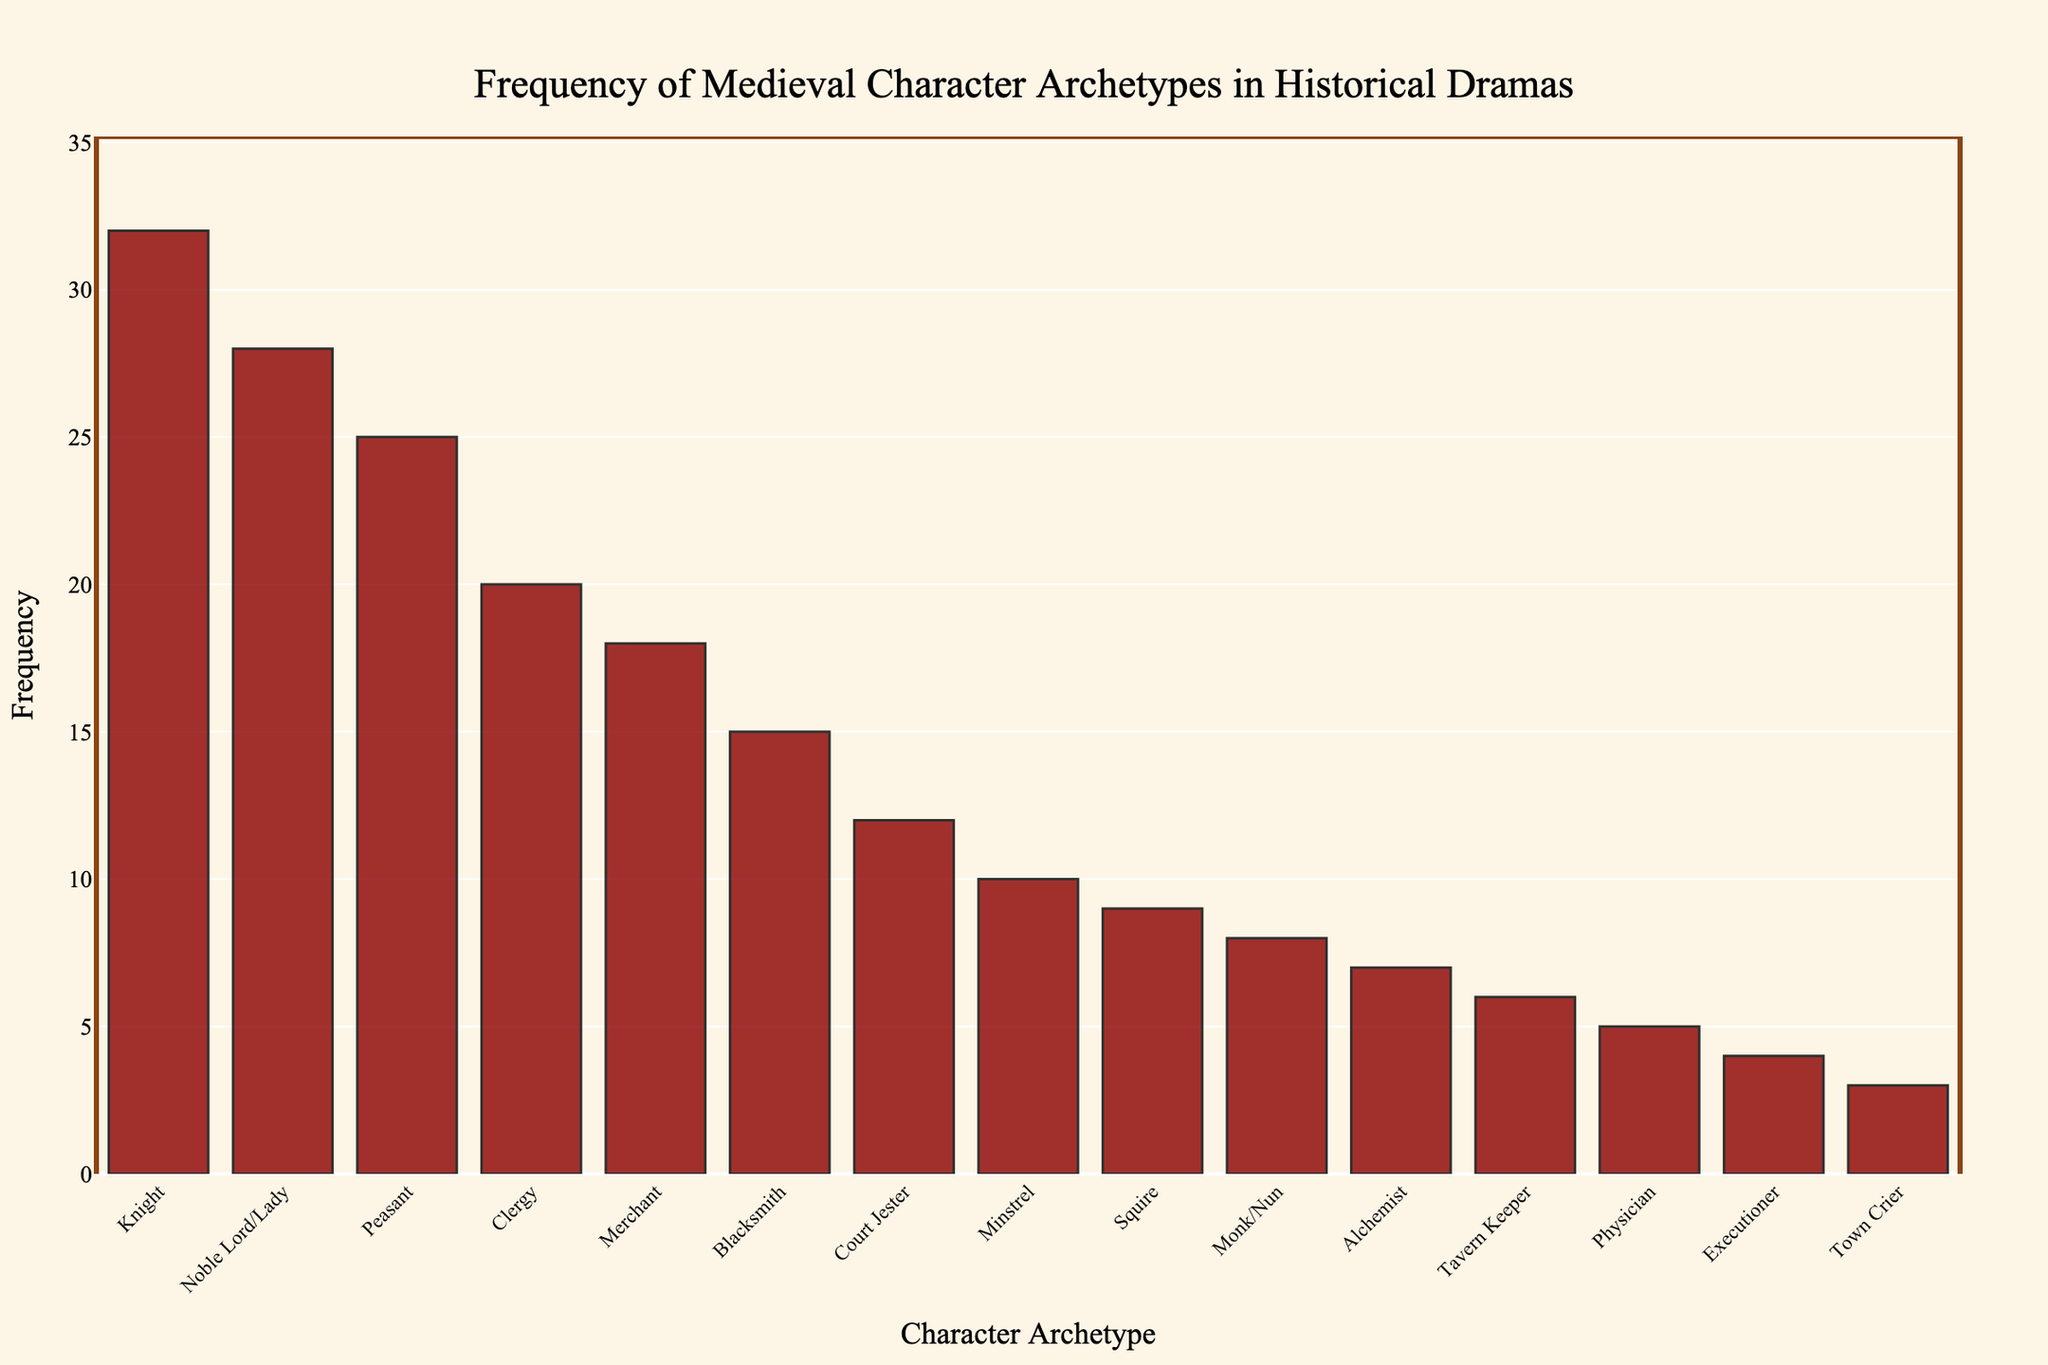Which character archetype appears most frequently in historical dramas? The tallest bar represents the frequency of the most common archetype in the chart. The knight has the highest bar.
Answer: Knight Which character archetype appears least frequently in historical dramas? The smallest bar represents the frequency of the least common archetype. The Town Crier has the shortest bar.
Answer: Town Crier What is the combined frequency of the Knight and the Noble Lord/Lady archetypes? Add the frequencies of the Knight and the Noble Lord/Lady archetypes. Knight: 32, Noble Lord/Lady: 28. Combined frequency = 32 + 28.
Answer: 60 How does the frequency of the Peasant archetype compare to that of the Merchant? Compare the heights of the bars representing the Peasant and the Merchant. Peasant (25) is higher than Merchant (18), so the Peasant archetype is more frequent.
Answer: Peasant is more frequent What is the difference in frequency between the Blacksmith and the Executioner archetypes? Subtract the frequency of the Executioner (4) from the frequency of the Blacksmith (15). Difference = 15 - 4.
Answer: 11 Which archetype is more frequent: Minstrel or Monk/Nun? Compare the heights of the bars representing Minstrel (10) and Monk/Nun (8). The Minstrel's bar is higher.
Answer: Minstrel What is the average frequency of the top three most frequent archetypes? Find the frequencies of the top three archetypes and then calculate the average. Top three: Knight (32), Noble Lord/Lady (28), Peasant (25). Average = (32 + 28 + 25) / 3.
Answer: 28.33 How many archetypes have a frequency greater than 20? Count the number of bars that have a height greater than 20. The archetypes with frequencies > 20 are Knight, Noble Lord/Lady, and Peasant.
Answer: 3 What is the total frequency of all the archetypes portrayed in historical dramas? Sum the frequencies of all archetypes. Total = 32 + 28 + 25 + 20 + 18 + 15 + 12 + 10 + 9 + 8 + 7 + 6 + 5 + 4 + 3.
Answer: 202 How many more times frequent are Knights compared to Alchemists? Divide the frequency of the Knight (32) by the frequency of the Alchemist (7). Number of times = 32 / 7.
Answer: 4.57 